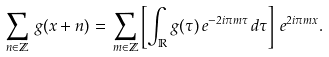Convert formula to latex. <formula><loc_0><loc_0><loc_500><loc_500>\sum _ { n \in \mathbb { Z } } \, g ( x + n ) = \, \sum _ { m \in \mathbb { Z } } \left [ \int _ { \mathbb { R } } g ( \tau ) \, e ^ { - 2 i \pi m \tau } \, d \tau \right ] \, e ^ { 2 i \pi m x } .</formula> 